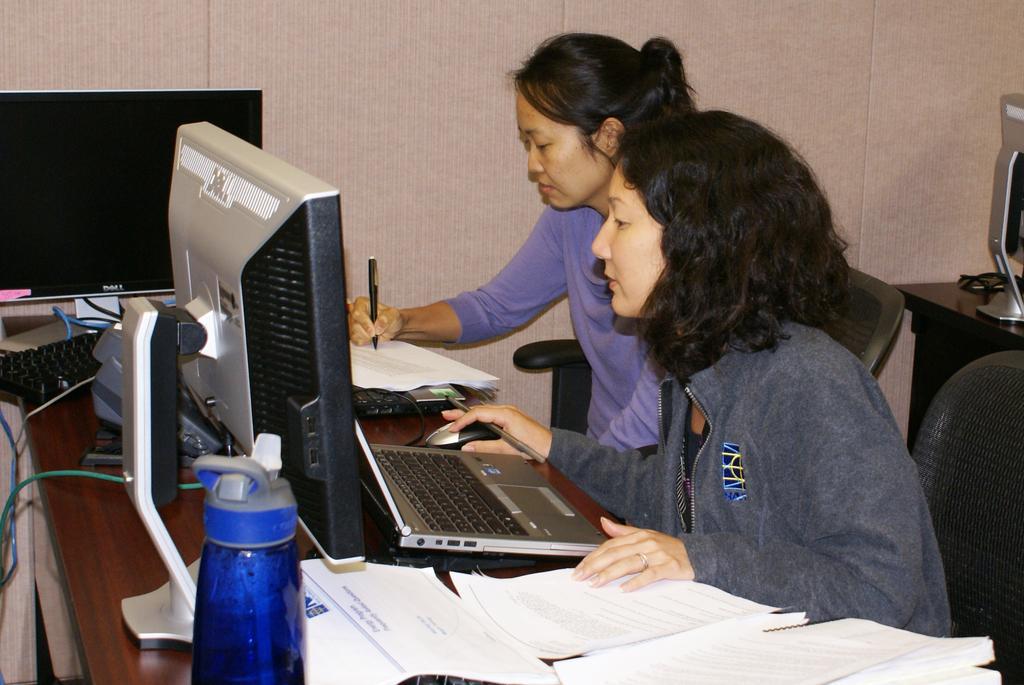Please provide a concise description of this image. There are two women sitting on the chairs. This is the table with two monitors, a laptop, two keyboards and papers. I can see a woman operating the mouse and holding a pen. Here is the another woman writing with the pen on the paper. This looks like another table with a monitor on it. I think this is the wall. 